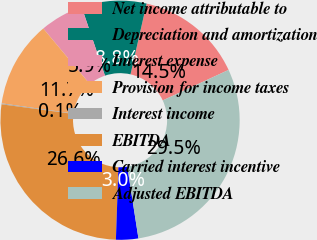<chart> <loc_0><loc_0><loc_500><loc_500><pie_chart><fcel>Net income attributable to<fcel>Depreciation and amortization<fcel>Interest expense<fcel>Provision for income taxes<fcel>Interest income<fcel>EBITDA<fcel>Carried interest incentive<fcel>Adjusted EBITDA<nl><fcel>14.53%<fcel>8.77%<fcel>5.89%<fcel>11.65%<fcel>0.13%<fcel>26.57%<fcel>3.01%<fcel>29.45%<nl></chart> 